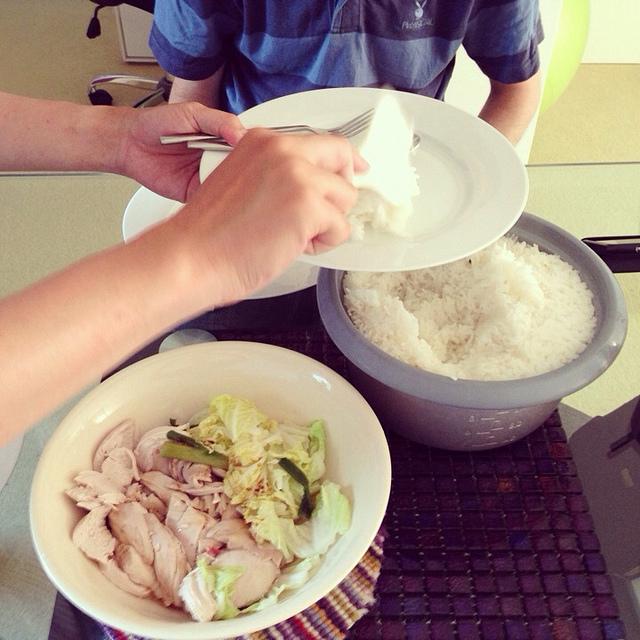What utensil can be seen?
Answer briefly. Fork. Is that rice?
Write a very short answer. Yes. Could this be considered an Asian meal?
Concise answer only. Yes. 